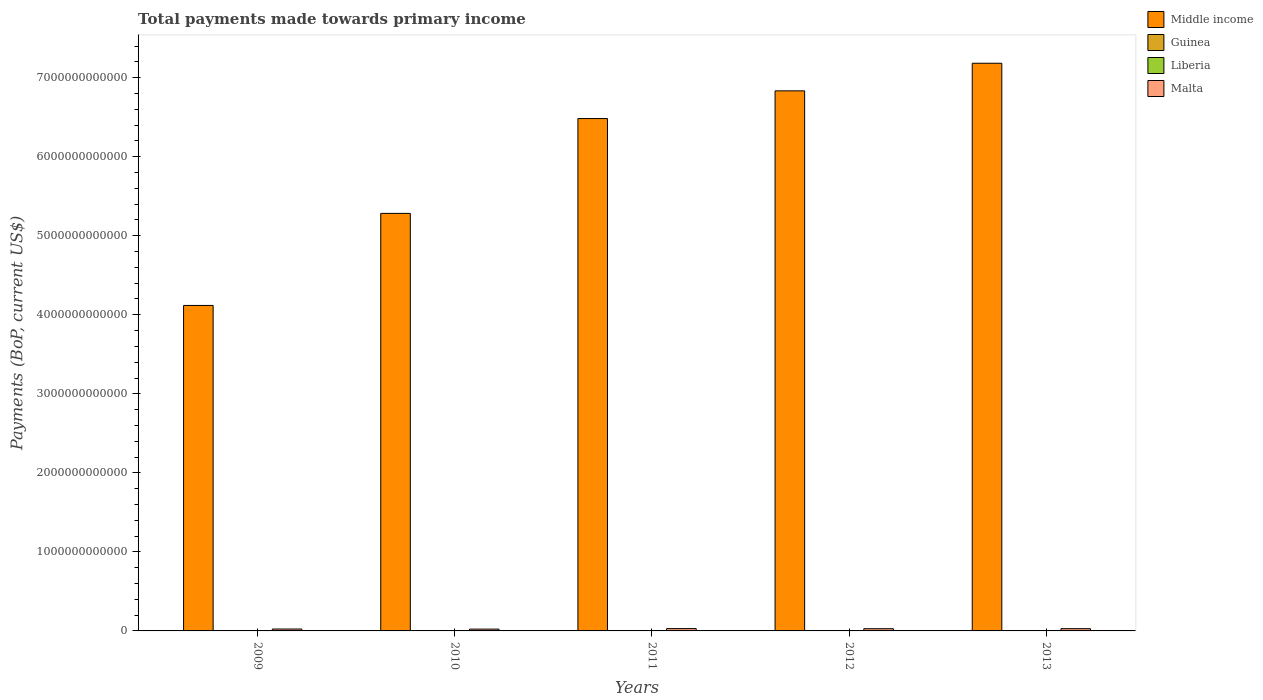How many groups of bars are there?
Make the answer very short. 5. Are the number of bars per tick equal to the number of legend labels?
Give a very brief answer. Yes. How many bars are there on the 1st tick from the left?
Offer a very short reply. 4. What is the label of the 1st group of bars from the left?
Give a very brief answer. 2009. What is the total payments made towards primary income in Guinea in 2013?
Provide a succinct answer. 3.24e+09. Across all years, what is the maximum total payments made towards primary income in Liberia?
Offer a very short reply. 3.33e+09. Across all years, what is the minimum total payments made towards primary income in Liberia?
Provide a short and direct response. 1.80e+09. What is the total total payments made towards primary income in Malta in the graph?
Offer a very short reply. 1.33e+11. What is the difference between the total payments made towards primary income in Middle income in 2011 and that in 2013?
Provide a succinct answer. -7.00e+11. What is the difference between the total payments made towards primary income in Liberia in 2009 and the total payments made towards primary income in Guinea in 2013?
Offer a very short reply. -1.39e+09. What is the average total payments made towards primary income in Middle income per year?
Provide a succinct answer. 5.98e+12. In the year 2009, what is the difference between the total payments made towards primary income in Middle income and total payments made towards primary income in Malta?
Keep it short and to the point. 4.09e+12. In how many years, is the total payments made towards primary income in Liberia greater than 1000000000000 US$?
Your answer should be compact. 0. What is the ratio of the total payments made towards primary income in Middle income in 2009 to that in 2011?
Keep it short and to the point. 0.64. What is the difference between the highest and the second highest total payments made towards primary income in Malta?
Offer a terse response. 8.37e+08. What is the difference between the highest and the lowest total payments made towards primary income in Middle income?
Ensure brevity in your answer.  3.06e+12. In how many years, is the total payments made towards primary income in Malta greater than the average total payments made towards primary income in Malta taken over all years?
Offer a terse response. 3. Is the sum of the total payments made towards primary income in Liberia in 2010 and 2013 greater than the maximum total payments made towards primary income in Guinea across all years?
Give a very brief answer. Yes. What does the 2nd bar from the right in 2010 represents?
Provide a short and direct response. Liberia. How many bars are there?
Ensure brevity in your answer.  20. Are all the bars in the graph horizontal?
Provide a short and direct response. No. What is the difference between two consecutive major ticks on the Y-axis?
Offer a very short reply. 1.00e+12. Are the values on the major ticks of Y-axis written in scientific E-notation?
Keep it short and to the point. No. How many legend labels are there?
Your response must be concise. 4. How are the legend labels stacked?
Make the answer very short. Vertical. What is the title of the graph?
Offer a very short reply. Total payments made towards primary income. Does "Honduras" appear as one of the legend labels in the graph?
Offer a terse response. No. What is the label or title of the Y-axis?
Make the answer very short. Payments (BoP, current US$). What is the Payments (BoP, current US$) in Middle income in 2009?
Keep it short and to the point. 4.12e+12. What is the Payments (BoP, current US$) of Guinea in 2009?
Make the answer very short. 1.58e+09. What is the Payments (BoP, current US$) of Liberia in 2009?
Give a very brief answer. 1.85e+09. What is the Payments (BoP, current US$) of Malta in 2009?
Keep it short and to the point. 2.41e+1. What is the Payments (BoP, current US$) of Middle income in 2010?
Your answer should be compact. 5.28e+12. What is the Payments (BoP, current US$) in Guinea in 2010?
Give a very brief answer. 1.89e+09. What is the Payments (BoP, current US$) in Liberia in 2010?
Your answer should be very brief. 1.80e+09. What is the Payments (BoP, current US$) of Malta in 2010?
Give a very brief answer. 2.28e+1. What is the Payments (BoP, current US$) in Middle income in 2011?
Ensure brevity in your answer.  6.48e+12. What is the Payments (BoP, current US$) in Guinea in 2011?
Provide a short and direct response. 2.83e+09. What is the Payments (BoP, current US$) of Liberia in 2011?
Offer a terse response. 3.33e+09. What is the Payments (BoP, current US$) in Malta in 2011?
Keep it short and to the point. 2.94e+1. What is the Payments (BoP, current US$) in Middle income in 2012?
Offer a terse response. 6.83e+12. What is the Payments (BoP, current US$) in Guinea in 2012?
Provide a succinct answer. 3.29e+09. What is the Payments (BoP, current US$) in Liberia in 2012?
Provide a short and direct response. 2.32e+09. What is the Payments (BoP, current US$) of Malta in 2012?
Your answer should be very brief. 2.80e+1. What is the Payments (BoP, current US$) in Middle income in 2013?
Offer a very short reply. 7.18e+12. What is the Payments (BoP, current US$) of Guinea in 2013?
Make the answer very short. 3.24e+09. What is the Payments (BoP, current US$) of Liberia in 2013?
Keep it short and to the point. 2.36e+09. What is the Payments (BoP, current US$) in Malta in 2013?
Your answer should be compact. 2.86e+1. Across all years, what is the maximum Payments (BoP, current US$) of Middle income?
Provide a short and direct response. 7.18e+12. Across all years, what is the maximum Payments (BoP, current US$) in Guinea?
Provide a short and direct response. 3.29e+09. Across all years, what is the maximum Payments (BoP, current US$) of Liberia?
Provide a succinct answer. 3.33e+09. Across all years, what is the maximum Payments (BoP, current US$) of Malta?
Give a very brief answer. 2.94e+1. Across all years, what is the minimum Payments (BoP, current US$) of Middle income?
Your answer should be very brief. 4.12e+12. Across all years, what is the minimum Payments (BoP, current US$) of Guinea?
Offer a very short reply. 1.58e+09. Across all years, what is the minimum Payments (BoP, current US$) of Liberia?
Your response must be concise. 1.80e+09. Across all years, what is the minimum Payments (BoP, current US$) of Malta?
Make the answer very short. 2.28e+1. What is the total Payments (BoP, current US$) of Middle income in the graph?
Offer a terse response. 2.99e+13. What is the total Payments (BoP, current US$) of Guinea in the graph?
Make the answer very short. 1.28e+1. What is the total Payments (BoP, current US$) in Liberia in the graph?
Ensure brevity in your answer.  1.17e+1. What is the total Payments (BoP, current US$) of Malta in the graph?
Give a very brief answer. 1.33e+11. What is the difference between the Payments (BoP, current US$) in Middle income in 2009 and that in 2010?
Offer a very short reply. -1.16e+12. What is the difference between the Payments (BoP, current US$) of Guinea in 2009 and that in 2010?
Provide a short and direct response. -3.11e+08. What is the difference between the Payments (BoP, current US$) in Liberia in 2009 and that in 2010?
Provide a succinct answer. 4.54e+07. What is the difference between the Payments (BoP, current US$) of Malta in 2009 and that in 2010?
Provide a short and direct response. 1.27e+09. What is the difference between the Payments (BoP, current US$) in Middle income in 2009 and that in 2011?
Offer a terse response. -2.36e+12. What is the difference between the Payments (BoP, current US$) of Guinea in 2009 and that in 2011?
Offer a terse response. -1.25e+09. What is the difference between the Payments (BoP, current US$) of Liberia in 2009 and that in 2011?
Ensure brevity in your answer.  -1.48e+09. What is the difference between the Payments (BoP, current US$) in Malta in 2009 and that in 2011?
Make the answer very short. -5.32e+09. What is the difference between the Payments (BoP, current US$) of Middle income in 2009 and that in 2012?
Provide a short and direct response. -2.72e+12. What is the difference between the Payments (BoP, current US$) in Guinea in 2009 and that in 2012?
Your response must be concise. -1.71e+09. What is the difference between the Payments (BoP, current US$) in Liberia in 2009 and that in 2012?
Keep it short and to the point. -4.67e+08. What is the difference between the Payments (BoP, current US$) in Malta in 2009 and that in 2012?
Your answer should be compact. -3.93e+09. What is the difference between the Payments (BoP, current US$) in Middle income in 2009 and that in 2013?
Your response must be concise. -3.06e+12. What is the difference between the Payments (BoP, current US$) of Guinea in 2009 and that in 2013?
Make the answer very short. -1.66e+09. What is the difference between the Payments (BoP, current US$) of Liberia in 2009 and that in 2013?
Keep it short and to the point. -5.12e+08. What is the difference between the Payments (BoP, current US$) of Malta in 2009 and that in 2013?
Your answer should be compact. -4.49e+09. What is the difference between the Payments (BoP, current US$) in Middle income in 2010 and that in 2011?
Ensure brevity in your answer.  -1.20e+12. What is the difference between the Payments (BoP, current US$) in Guinea in 2010 and that in 2011?
Provide a succinct answer. -9.36e+08. What is the difference between the Payments (BoP, current US$) of Liberia in 2010 and that in 2011?
Your answer should be very brief. -1.52e+09. What is the difference between the Payments (BoP, current US$) of Malta in 2010 and that in 2011?
Offer a very short reply. -6.59e+09. What is the difference between the Payments (BoP, current US$) of Middle income in 2010 and that in 2012?
Your answer should be very brief. -1.55e+12. What is the difference between the Payments (BoP, current US$) in Guinea in 2010 and that in 2012?
Your response must be concise. -1.40e+09. What is the difference between the Payments (BoP, current US$) of Liberia in 2010 and that in 2012?
Ensure brevity in your answer.  -5.12e+08. What is the difference between the Payments (BoP, current US$) of Malta in 2010 and that in 2012?
Keep it short and to the point. -5.20e+09. What is the difference between the Payments (BoP, current US$) in Middle income in 2010 and that in 2013?
Offer a terse response. -1.90e+12. What is the difference between the Payments (BoP, current US$) of Guinea in 2010 and that in 2013?
Offer a terse response. -1.35e+09. What is the difference between the Payments (BoP, current US$) of Liberia in 2010 and that in 2013?
Keep it short and to the point. -5.57e+08. What is the difference between the Payments (BoP, current US$) of Malta in 2010 and that in 2013?
Ensure brevity in your answer.  -5.75e+09. What is the difference between the Payments (BoP, current US$) in Middle income in 2011 and that in 2012?
Your answer should be compact. -3.51e+11. What is the difference between the Payments (BoP, current US$) of Guinea in 2011 and that in 2012?
Provide a short and direct response. -4.60e+08. What is the difference between the Payments (BoP, current US$) in Liberia in 2011 and that in 2012?
Offer a very short reply. 1.01e+09. What is the difference between the Payments (BoP, current US$) in Malta in 2011 and that in 2012?
Keep it short and to the point. 1.39e+09. What is the difference between the Payments (BoP, current US$) in Middle income in 2011 and that in 2013?
Provide a succinct answer. -7.00e+11. What is the difference between the Payments (BoP, current US$) in Guinea in 2011 and that in 2013?
Keep it short and to the point. -4.13e+08. What is the difference between the Payments (BoP, current US$) of Liberia in 2011 and that in 2013?
Provide a short and direct response. 9.63e+08. What is the difference between the Payments (BoP, current US$) of Malta in 2011 and that in 2013?
Make the answer very short. 8.37e+08. What is the difference between the Payments (BoP, current US$) in Middle income in 2012 and that in 2013?
Provide a succinct answer. -3.49e+11. What is the difference between the Payments (BoP, current US$) in Guinea in 2012 and that in 2013?
Offer a very short reply. 4.70e+07. What is the difference between the Payments (BoP, current US$) of Liberia in 2012 and that in 2013?
Offer a terse response. -4.49e+07. What is the difference between the Payments (BoP, current US$) in Malta in 2012 and that in 2013?
Make the answer very short. -5.52e+08. What is the difference between the Payments (BoP, current US$) of Middle income in 2009 and the Payments (BoP, current US$) of Guinea in 2010?
Offer a very short reply. 4.12e+12. What is the difference between the Payments (BoP, current US$) of Middle income in 2009 and the Payments (BoP, current US$) of Liberia in 2010?
Your response must be concise. 4.12e+12. What is the difference between the Payments (BoP, current US$) in Middle income in 2009 and the Payments (BoP, current US$) in Malta in 2010?
Offer a terse response. 4.10e+12. What is the difference between the Payments (BoP, current US$) of Guinea in 2009 and the Payments (BoP, current US$) of Liberia in 2010?
Your answer should be very brief. -2.23e+08. What is the difference between the Payments (BoP, current US$) of Guinea in 2009 and the Payments (BoP, current US$) of Malta in 2010?
Provide a succinct answer. -2.12e+1. What is the difference between the Payments (BoP, current US$) of Liberia in 2009 and the Payments (BoP, current US$) of Malta in 2010?
Offer a terse response. -2.10e+1. What is the difference between the Payments (BoP, current US$) in Middle income in 2009 and the Payments (BoP, current US$) in Guinea in 2011?
Your answer should be very brief. 4.12e+12. What is the difference between the Payments (BoP, current US$) in Middle income in 2009 and the Payments (BoP, current US$) in Liberia in 2011?
Keep it short and to the point. 4.11e+12. What is the difference between the Payments (BoP, current US$) of Middle income in 2009 and the Payments (BoP, current US$) of Malta in 2011?
Provide a short and direct response. 4.09e+12. What is the difference between the Payments (BoP, current US$) in Guinea in 2009 and the Payments (BoP, current US$) in Liberia in 2011?
Provide a succinct answer. -1.74e+09. What is the difference between the Payments (BoP, current US$) in Guinea in 2009 and the Payments (BoP, current US$) in Malta in 2011?
Your answer should be compact. -2.78e+1. What is the difference between the Payments (BoP, current US$) of Liberia in 2009 and the Payments (BoP, current US$) of Malta in 2011?
Provide a short and direct response. -2.76e+1. What is the difference between the Payments (BoP, current US$) in Middle income in 2009 and the Payments (BoP, current US$) in Guinea in 2012?
Ensure brevity in your answer.  4.11e+12. What is the difference between the Payments (BoP, current US$) of Middle income in 2009 and the Payments (BoP, current US$) of Liberia in 2012?
Provide a succinct answer. 4.12e+12. What is the difference between the Payments (BoP, current US$) in Middle income in 2009 and the Payments (BoP, current US$) in Malta in 2012?
Offer a terse response. 4.09e+12. What is the difference between the Payments (BoP, current US$) of Guinea in 2009 and the Payments (BoP, current US$) of Liberia in 2012?
Make the answer very short. -7.36e+08. What is the difference between the Payments (BoP, current US$) of Guinea in 2009 and the Payments (BoP, current US$) of Malta in 2012?
Your answer should be compact. -2.64e+1. What is the difference between the Payments (BoP, current US$) in Liberia in 2009 and the Payments (BoP, current US$) in Malta in 2012?
Offer a very short reply. -2.62e+1. What is the difference between the Payments (BoP, current US$) of Middle income in 2009 and the Payments (BoP, current US$) of Guinea in 2013?
Offer a terse response. 4.11e+12. What is the difference between the Payments (BoP, current US$) of Middle income in 2009 and the Payments (BoP, current US$) of Liberia in 2013?
Your response must be concise. 4.12e+12. What is the difference between the Payments (BoP, current US$) in Middle income in 2009 and the Payments (BoP, current US$) in Malta in 2013?
Keep it short and to the point. 4.09e+12. What is the difference between the Payments (BoP, current US$) in Guinea in 2009 and the Payments (BoP, current US$) in Liberia in 2013?
Your answer should be compact. -7.81e+08. What is the difference between the Payments (BoP, current US$) in Guinea in 2009 and the Payments (BoP, current US$) in Malta in 2013?
Offer a very short reply. -2.70e+1. What is the difference between the Payments (BoP, current US$) of Liberia in 2009 and the Payments (BoP, current US$) of Malta in 2013?
Offer a terse response. -2.67e+1. What is the difference between the Payments (BoP, current US$) of Middle income in 2010 and the Payments (BoP, current US$) of Guinea in 2011?
Ensure brevity in your answer.  5.28e+12. What is the difference between the Payments (BoP, current US$) of Middle income in 2010 and the Payments (BoP, current US$) of Liberia in 2011?
Offer a very short reply. 5.28e+12. What is the difference between the Payments (BoP, current US$) in Middle income in 2010 and the Payments (BoP, current US$) in Malta in 2011?
Your answer should be compact. 5.25e+12. What is the difference between the Payments (BoP, current US$) in Guinea in 2010 and the Payments (BoP, current US$) in Liberia in 2011?
Your answer should be compact. -1.43e+09. What is the difference between the Payments (BoP, current US$) of Guinea in 2010 and the Payments (BoP, current US$) of Malta in 2011?
Give a very brief answer. -2.75e+1. What is the difference between the Payments (BoP, current US$) of Liberia in 2010 and the Payments (BoP, current US$) of Malta in 2011?
Keep it short and to the point. -2.76e+1. What is the difference between the Payments (BoP, current US$) of Middle income in 2010 and the Payments (BoP, current US$) of Guinea in 2012?
Provide a succinct answer. 5.28e+12. What is the difference between the Payments (BoP, current US$) of Middle income in 2010 and the Payments (BoP, current US$) of Liberia in 2012?
Your answer should be compact. 5.28e+12. What is the difference between the Payments (BoP, current US$) of Middle income in 2010 and the Payments (BoP, current US$) of Malta in 2012?
Your answer should be compact. 5.25e+12. What is the difference between the Payments (BoP, current US$) in Guinea in 2010 and the Payments (BoP, current US$) in Liberia in 2012?
Provide a short and direct response. -4.25e+08. What is the difference between the Payments (BoP, current US$) of Guinea in 2010 and the Payments (BoP, current US$) of Malta in 2012?
Make the answer very short. -2.61e+1. What is the difference between the Payments (BoP, current US$) in Liberia in 2010 and the Payments (BoP, current US$) in Malta in 2012?
Your answer should be very brief. -2.62e+1. What is the difference between the Payments (BoP, current US$) of Middle income in 2010 and the Payments (BoP, current US$) of Guinea in 2013?
Provide a short and direct response. 5.28e+12. What is the difference between the Payments (BoP, current US$) of Middle income in 2010 and the Payments (BoP, current US$) of Liberia in 2013?
Provide a succinct answer. 5.28e+12. What is the difference between the Payments (BoP, current US$) in Middle income in 2010 and the Payments (BoP, current US$) in Malta in 2013?
Offer a terse response. 5.25e+12. What is the difference between the Payments (BoP, current US$) of Guinea in 2010 and the Payments (BoP, current US$) of Liberia in 2013?
Provide a succinct answer. -4.70e+08. What is the difference between the Payments (BoP, current US$) in Guinea in 2010 and the Payments (BoP, current US$) in Malta in 2013?
Provide a succinct answer. -2.67e+1. What is the difference between the Payments (BoP, current US$) in Liberia in 2010 and the Payments (BoP, current US$) in Malta in 2013?
Keep it short and to the point. -2.68e+1. What is the difference between the Payments (BoP, current US$) of Middle income in 2011 and the Payments (BoP, current US$) of Guinea in 2012?
Offer a terse response. 6.48e+12. What is the difference between the Payments (BoP, current US$) in Middle income in 2011 and the Payments (BoP, current US$) in Liberia in 2012?
Keep it short and to the point. 6.48e+12. What is the difference between the Payments (BoP, current US$) in Middle income in 2011 and the Payments (BoP, current US$) in Malta in 2012?
Offer a very short reply. 6.45e+12. What is the difference between the Payments (BoP, current US$) in Guinea in 2011 and the Payments (BoP, current US$) in Liberia in 2012?
Ensure brevity in your answer.  5.12e+08. What is the difference between the Payments (BoP, current US$) in Guinea in 2011 and the Payments (BoP, current US$) in Malta in 2012?
Provide a succinct answer. -2.52e+1. What is the difference between the Payments (BoP, current US$) in Liberia in 2011 and the Payments (BoP, current US$) in Malta in 2012?
Provide a succinct answer. -2.47e+1. What is the difference between the Payments (BoP, current US$) of Middle income in 2011 and the Payments (BoP, current US$) of Guinea in 2013?
Your answer should be compact. 6.48e+12. What is the difference between the Payments (BoP, current US$) of Middle income in 2011 and the Payments (BoP, current US$) of Liberia in 2013?
Your answer should be very brief. 6.48e+12. What is the difference between the Payments (BoP, current US$) in Middle income in 2011 and the Payments (BoP, current US$) in Malta in 2013?
Provide a succinct answer. 6.45e+12. What is the difference between the Payments (BoP, current US$) of Guinea in 2011 and the Payments (BoP, current US$) of Liberia in 2013?
Your answer should be very brief. 4.67e+08. What is the difference between the Payments (BoP, current US$) of Guinea in 2011 and the Payments (BoP, current US$) of Malta in 2013?
Your answer should be very brief. -2.57e+1. What is the difference between the Payments (BoP, current US$) of Liberia in 2011 and the Payments (BoP, current US$) of Malta in 2013?
Your answer should be compact. -2.52e+1. What is the difference between the Payments (BoP, current US$) of Middle income in 2012 and the Payments (BoP, current US$) of Guinea in 2013?
Your response must be concise. 6.83e+12. What is the difference between the Payments (BoP, current US$) in Middle income in 2012 and the Payments (BoP, current US$) in Liberia in 2013?
Offer a terse response. 6.83e+12. What is the difference between the Payments (BoP, current US$) in Middle income in 2012 and the Payments (BoP, current US$) in Malta in 2013?
Your response must be concise. 6.80e+12. What is the difference between the Payments (BoP, current US$) in Guinea in 2012 and the Payments (BoP, current US$) in Liberia in 2013?
Ensure brevity in your answer.  9.27e+08. What is the difference between the Payments (BoP, current US$) of Guinea in 2012 and the Payments (BoP, current US$) of Malta in 2013?
Give a very brief answer. -2.53e+1. What is the difference between the Payments (BoP, current US$) in Liberia in 2012 and the Payments (BoP, current US$) in Malta in 2013?
Your answer should be very brief. -2.62e+1. What is the average Payments (BoP, current US$) of Middle income per year?
Ensure brevity in your answer.  5.98e+12. What is the average Payments (BoP, current US$) of Guinea per year?
Provide a succinct answer. 2.57e+09. What is the average Payments (BoP, current US$) of Liberia per year?
Your answer should be very brief. 2.33e+09. What is the average Payments (BoP, current US$) of Malta per year?
Keep it short and to the point. 2.66e+1. In the year 2009, what is the difference between the Payments (BoP, current US$) of Middle income and Payments (BoP, current US$) of Guinea?
Give a very brief answer. 4.12e+12. In the year 2009, what is the difference between the Payments (BoP, current US$) in Middle income and Payments (BoP, current US$) in Liberia?
Offer a very short reply. 4.12e+12. In the year 2009, what is the difference between the Payments (BoP, current US$) in Middle income and Payments (BoP, current US$) in Malta?
Ensure brevity in your answer.  4.09e+12. In the year 2009, what is the difference between the Payments (BoP, current US$) of Guinea and Payments (BoP, current US$) of Liberia?
Your answer should be compact. -2.69e+08. In the year 2009, what is the difference between the Payments (BoP, current US$) in Guinea and Payments (BoP, current US$) in Malta?
Keep it short and to the point. -2.25e+1. In the year 2009, what is the difference between the Payments (BoP, current US$) in Liberia and Payments (BoP, current US$) in Malta?
Give a very brief answer. -2.22e+1. In the year 2010, what is the difference between the Payments (BoP, current US$) in Middle income and Payments (BoP, current US$) in Guinea?
Your answer should be very brief. 5.28e+12. In the year 2010, what is the difference between the Payments (BoP, current US$) in Middle income and Payments (BoP, current US$) in Liberia?
Your response must be concise. 5.28e+12. In the year 2010, what is the difference between the Payments (BoP, current US$) of Middle income and Payments (BoP, current US$) of Malta?
Keep it short and to the point. 5.26e+12. In the year 2010, what is the difference between the Payments (BoP, current US$) of Guinea and Payments (BoP, current US$) of Liberia?
Your answer should be very brief. 8.78e+07. In the year 2010, what is the difference between the Payments (BoP, current US$) of Guinea and Payments (BoP, current US$) of Malta?
Your response must be concise. -2.09e+1. In the year 2010, what is the difference between the Payments (BoP, current US$) of Liberia and Payments (BoP, current US$) of Malta?
Provide a succinct answer. -2.10e+1. In the year 2011, what is the difference between the Payments (BoP, current US$) in Middle income and Payments (BoP, current US$) in Guinea?
Your answer should be compact. 6.48e+12. In the year 2011, what is the difference between the Payments (BoP, current US$) of Middle income and Payments (BoP, current US$) of Liberia?
Provide a short and direct response. 6.48e+12. In the year 2011, what is the difference between the Payments (BoP, current US$) in Middle income and Payments (BoP, current US$) in Malta?
Offer a terse response. 6.45e+12. In the year 2011, what is the difference between the Payments (BoP, current US$) in Guinea and Payments (BoP, current US$) in Liberia?
Your answer should be very brief. -4.96e+08. In the year 2011, what is the difference between the Payments (BoP, current US$) in Guinea and Payments (BoP, current US$) in Malta?
Your answer should be compact. -2.66e+1. In the year 2011, what is the difference between the Payments (BoP, current US$) in Liberia and Payments (BoP, current US$) in Malta?
Provide a succinct answer. -2.61e+1. In the year 2012, what is the difference between the Payments (BoP, current US$) of Middle income and Payments (BoP, current US$) of Guinea?
Offer a terse response. 6.83e+12. In the year 2012, what is the difference between the Payments (BoP, current US$) of Middle income and Payments (BoP, current US$) of Liberia?
Offer a terse response. 6.83e+12. In the year 2012, what is the difference between the Payments (BoP, current US$) in Middle income and Payments (BoP, current US$) in Malta?
Your answer should be very brief. 6.81e+12. In the year 2012, what is the difference between the Payments (BoP, current US$) of Guinea and Payments (BoP, current US$) of Liberia?
Your answer should be compact. 9.72e+08. In the year 2012, what is the difference between the Payments (BoP, current US$) in Guinea and Payments (BoP, current US$) in Malta?
Give a very brief answer. -2.47e+1. In the year 2012, what is the difference between the Payments (BoP, current US$) of Liberia and Payments (BoP, current US$) of Malta?
Ensure brevity in your answer.  -2.57e+1. In the year 2013, what is the difference between the Payments (BoP, current US$) of Middle income and Payments (BoP, current US$) of Guinea?
Provide a short and direct response. 7.18e+12. In the year 2013, what is the difference between the Payments (BoP, current US$) of Middle income and Payments (BoP, current US$) of Liberia?
Offer a very short reply. 7.18e+12. In the year 2013, what is the difference between the Payments (BoP, current US$) of Middle income and Payments (BoP, current US$) of Malta?
Make the answer very short. 7.15e+12. In the year 2013, what is the difference between the Payments (BoP, current US$) of Guinea and Payments (BoP, current US$) of Liberia?
Your answer should be very brief. 8.80e+08. In the year 2013, what is the difference between the Payments (BoP, current US$) in Guinea and Payments (BoP, current US$) in Malta?
Your response must be concise. -2.53e+1. In the year 2013, what is the difference between the Payments (BoP, current US$) in Liberia and Payments (BoP, current US$) in Malta?
Make the answer very short. -2.62e+1. What is the ratio of the Payments (BoP, current US$) in Middle income in 2009 to that in 2010?
Give a very brief answer. 0.78. What is the ratio of the Payments (BoP, current US$) of Guinea in 2009 to that in 2010?
Your answer should be very brief. 0.84. What is the ratio of the Payments (BoP, current US$) of Liberia in 2009 to that in 2010?
Offer a terse response. 1.03. What is the ratio of the Payments (BoP, current US$) in Malta in 2009 to that in 2010?
Your response must be concise. 1.06. What is the ratio of the Payments (BoP, current US$) in Middle income in 2009 to that in 2011?
Give a very brief answer. 0.64. What is the ratio of the Payments (BoP, current US$) of Guinea in 2009 to that in 2011?
Provide a succinct answer. 0.56. What is the ratio of the Payments (BoP, current US$) in Liberia in 2009 to that in 2011?
Offer a terse response. 0.56. What is the ratio of the Payments (BoP, current US$) of Malta in 2009 to that in 2011?
Make the answer very short. 0.82. What is the ratio of the Payments (BoP, current US$) of Middle income in 2009 to that in 2012?
Provide a succinct answer. 0.6. What is the ratio of the Payments (BoP, current US$) in Guinea in 2009 to that in 2012?
Give a very brief answer. 0.48. What is the ratio of the Payments (BoP, current US$) of Liberia in 2009 to that in 2012?
Provide a succinct answer. 0.8. What is the ratio of the Payments (BoP, current US$) in Malta in 2009 to that in 2012?
Your answer should be very brief. 0.86. What is the ratio of the Payments (BoP, current US$) in Middle income in 2009 to that in 2013?
Your response must be concise. 0.57. What is the ratio of the Payments (BoP, current US$) of Guinea in 2009 to that in 2013?
Your answer should be compact. 0.49. What is the ratio of the Payments (BoP, current US$) of Liberia in 2009 to that in 2013?
Give a very brief answer. 0.78. What is the ratio of the Payments (BoP, current US$) of Malta in 2009 to that in 2013?
Your answer should be compact. 0.84. What is the ratio of the Payments (BoP, current US$) of Middle income in 2010 to that in 2011?
Give a very brief answer. 0.81. What is the ratio of the Payments (BoP, current US$) of Guinea in 2010 to that in 2011?
Offer a terse response. 0.67. What is the ratio of the Payments (BoP, current US$) of Liberia in 2010 to that in 2011?
Make the answer very short. 0.54. What is the ratio of the Payments (BoP, current US$) in Malta in 2010 to that in 2011?
Ensure brevity in your answer.  0.78. What is the ratio of the Payments (BoP, current US$) in Middle income in 2010 to that in 2012?
Your response must be concise. 0.77. What is the ratio of the Payments (BoP, current US$) of Guinea in 2010 to that in 2012?
Provide a succinct answer. 0.58. What is the ratio of the Payments (BoP, current US$) of Liberia in 2010 to that in 2012?
Keep it short and to the point. 0.78. What is the ratio of the Payments (BoP, current US$) in Malta in 2010 to that in 2012?
Give a very brief answer. 0.81. What is the ratio of the Payments (BoP, current US$) of Middle income in 2010 to that in 2013?
Give a very brief answer. 0.74. What is the ratio of the Payments (BoP, current US$) in Guinea in 2010 to that in 2013?
Make the answer very short. 0.58. What is the ratio of the Payments (BoP, current US$) in Liberia in 2010 to that in 2013?
Ensure brevity in your answer.  0.76. What is the ratio of the Payments (BoP, current US$) of Malta in 2010 to that in 2013?
Give a very brief answer. 0.8. What is the ratio of the Payments (BoP, current US$) of Middle income in 2011 to that in 2012?
Your answer should be very brief. 0.95. What is the ratio of the Payments (BoP, current US$) in Guinea in 2011 to that in 2012?
Provide a succinct answer. 0.86. What is the ratio of the Payments (BoP, current US$) of Liberia in 2011 to that in 2012?
Offer a very short reply. 1.44. What is the ratio of the Payments (BoP, current US$) in Malta in 2011 to that in 2012?
Your answer should be compact. 1.05. What is the ratio of the Payments (BoP, current US$) in Middle income in 2011 to that in 2013?
Offer a terse response. 0.9. What is the ratio of the Payments (BoP, current US$) of Guinea in 2011 to that in 2013?
Offer a very short reply. 0.87. What is the ratio of the Payments (BoP, current US$) in Liberia in 2011 to that in 2013?
Offer a terse response. 1.41. What is the ratio of the Payments (BoP, current US$) in Malta in 2011 to that in 2013?
Give a very brief answer. 1.03. What is the ratio of the Payments (BoP, current US$) in Middle income in 2012 to that in 2013?
Your answer should be compact. 0.95. What is the ratio of the Payments (BoP, current US$) in Guinea in 2012 to that in 2013?
Your response must be concise. 1.01. What is the ratio of the Payments (BoP, current US$) of Malta in 2012 to that in 2013?
Ensure brevity in your answer.  0.98. What is the difference between the highest and the second highest Payments (BoP, current US$) in Middle income?
Give a very brief answer. 3.49e+11. What is the difference between the highest and the second highest Payments (BoP, current US$) in Guinea?
Your answer should be very brief. 4.70e+07. What is the difference between the highest and the second highest Payments (BoP, current US$) in Liberia?
Provide a succinct answer. 9.63e+08. What is the difference between the highest and the second highest Payments (BoP, current US$) in Malta?
Make the answer very short. 8.37e+08. What is the difference between the highest and the lowest Payments (BoP, current US$) of Middle income?
Your answer should be very brief. 3.06e+12. What is the difference between the highest and the lowest Payments (BoP, current US$) in Guinea?
Your response must be concise. 1.71e+09. What is the difference between the highest and the lowest Payments (BoP, current US$) in Liberia?
Offer a terse response. 1.52e+09. What is the difference between the highest and the lowest Payments (BoP, current US$) of Malta?
Offer a terse response. 6.59e+09. 